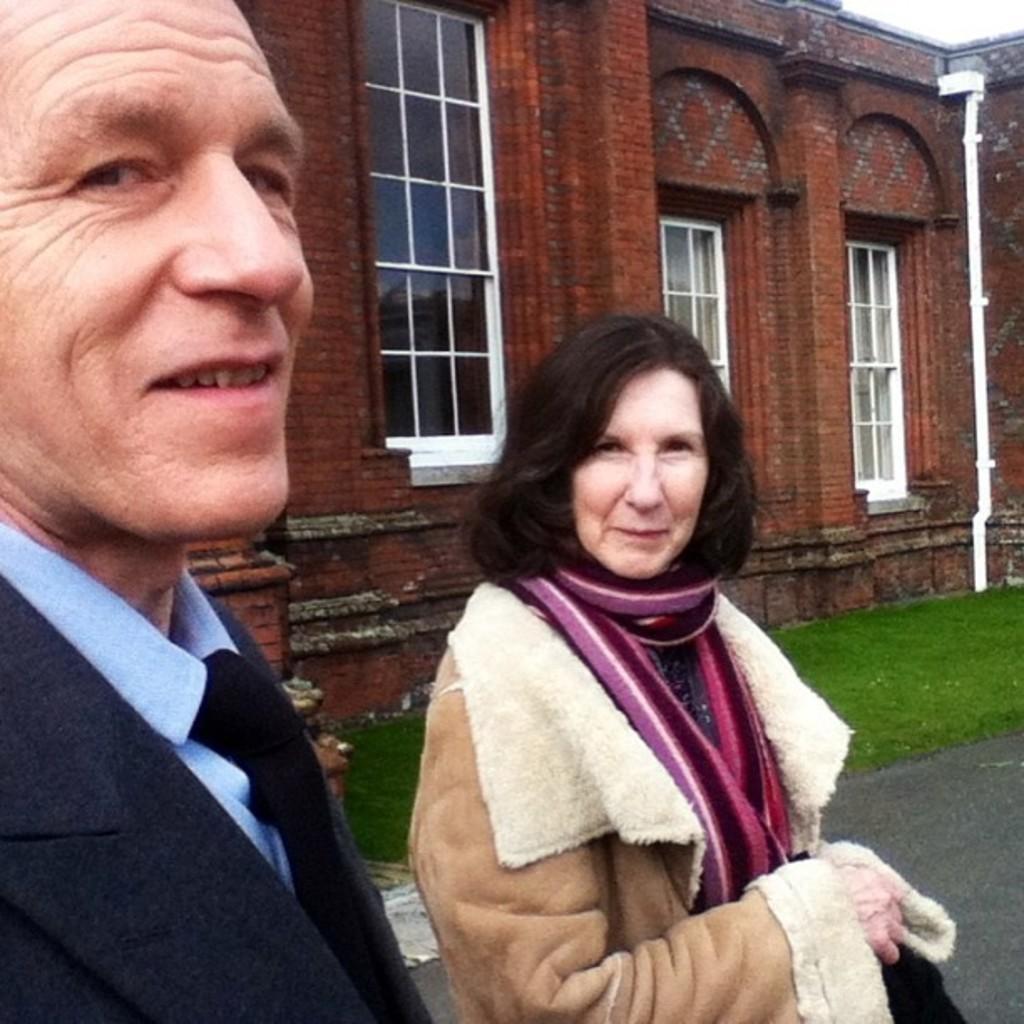Describe this image in one or two sentences. In the image we can see a man and a woman standing, wearing clothes and they are smiling. Here we can see the road, grass, a building and windows of the building 